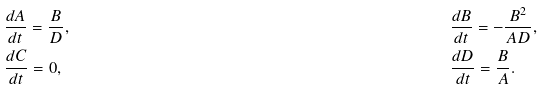Convert formula to latex. <formula><loc_0><loc_0><loc_500><loc_500>& \frac { d A } { d t } = \frac { B } { D } , & & \frac { d B } { d t } = - \frac { B ^ { 2 } } { A D } , \\ & \frac { d C } { d t } = 0 , & & \frac { d D } { d t } = \frac { B } { A } .</formula> 